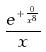Convert formula to latex. <formula><loc_0><loc_0><loc_500><loc_500>\frac { e ^ { + \frac { 0 } { x ^ { 8 } } } } { x }</formula> 